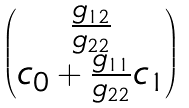<formula> <loc_0><loc_0><loc_500><loc_500>\begin{pmatrix} \frac { g _ { 1 2 } } { g _ { 2 2 } } \\ c _ { 0 } + \frac { g _ { 1 1 } } { g _ { 2 2 } } c _ { 1 } \end{pmatrix}</formula> 